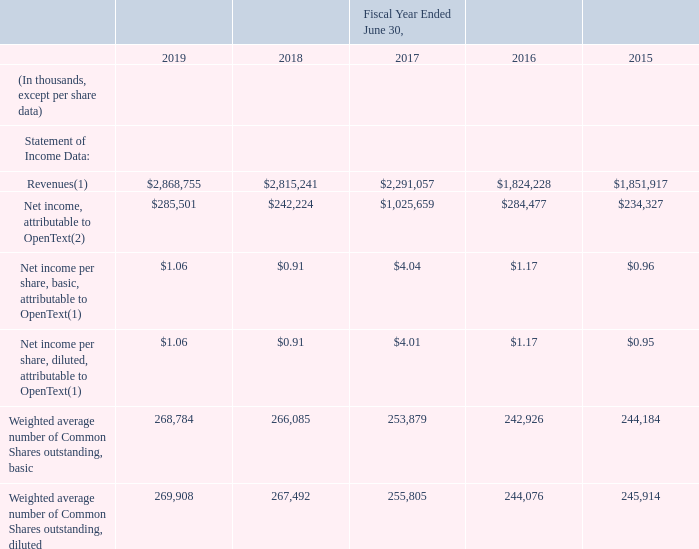Item 6. Selected Financial Data
The following table summarizes our selected consolidated financial data for the periods indicated. The selected consolidated financial data should be read in conjunction with our Consolidated Financial Statements and related notes and “Management's Discussion and Analysis of Financial Condition and Results of Operations” appearing elsewhere in this Annual Report on Form 10-K. The selected consolidated statement of income and balance sheet data for each of the five fiscal years indicated below has been derived from our audited Consolidated Financial Statements. Over the last five fiscal years we have acquired a number of companies including, but not limited to Catalyst, Liaison, Hightail, Guidance, Covisint, ECD Business, CCM Business, Recommind, ANX, CEM Business, Daegis, and Actuate. The results of these companies and all of our previously acquired companies have been included herein and have contributed to the growth in our revenues, net income and net income per share and such acquisitions affect period-to-period comparability.
(1) Effective July 1, 2018, we adopted Accounting Standards Codification (ASC) Topic 606 "Revenue from Contracts with Customers" (Topic 606) using the cumulative effect approach. We applied the standard to contracts that were not completed as of the date of the initial adoption. Results for reporting periods commencing on July 1, 2018 are presented under the new revenue standard, while prior period results continue to be reported under the previous standard.
(2) Fiscal 2017 included a significant one-time tax benefit of $876.1 million recorded in the first quarter of Fiscal 2017.
What does the table show? Summarizes our selected consolidated financial data for the periods indicated. In Fiscal 2017 how much was the tax benefit? $876.1 million. What units are used in this table? In thousands, except per share data. What is the Weighted average number of Common Shares outstanding, diluted for years 2017, 2018 and 2019? (269,908+267,492+255,805)/3
Answer: 264401.67. Excluding the one-tax benefit for Fiscal 2017, what is the Net income, attributable to the company for 2017?
Answer scale should be: thousand. 1,025,659 thousand-(876.1 million)
Answer: 149559. What is the percentage change of Revenues from 2015 to 2019? 
Answer scale should be: percent. (2,868,755-1,851,917)/1,851,917
Answer: 54.91. 